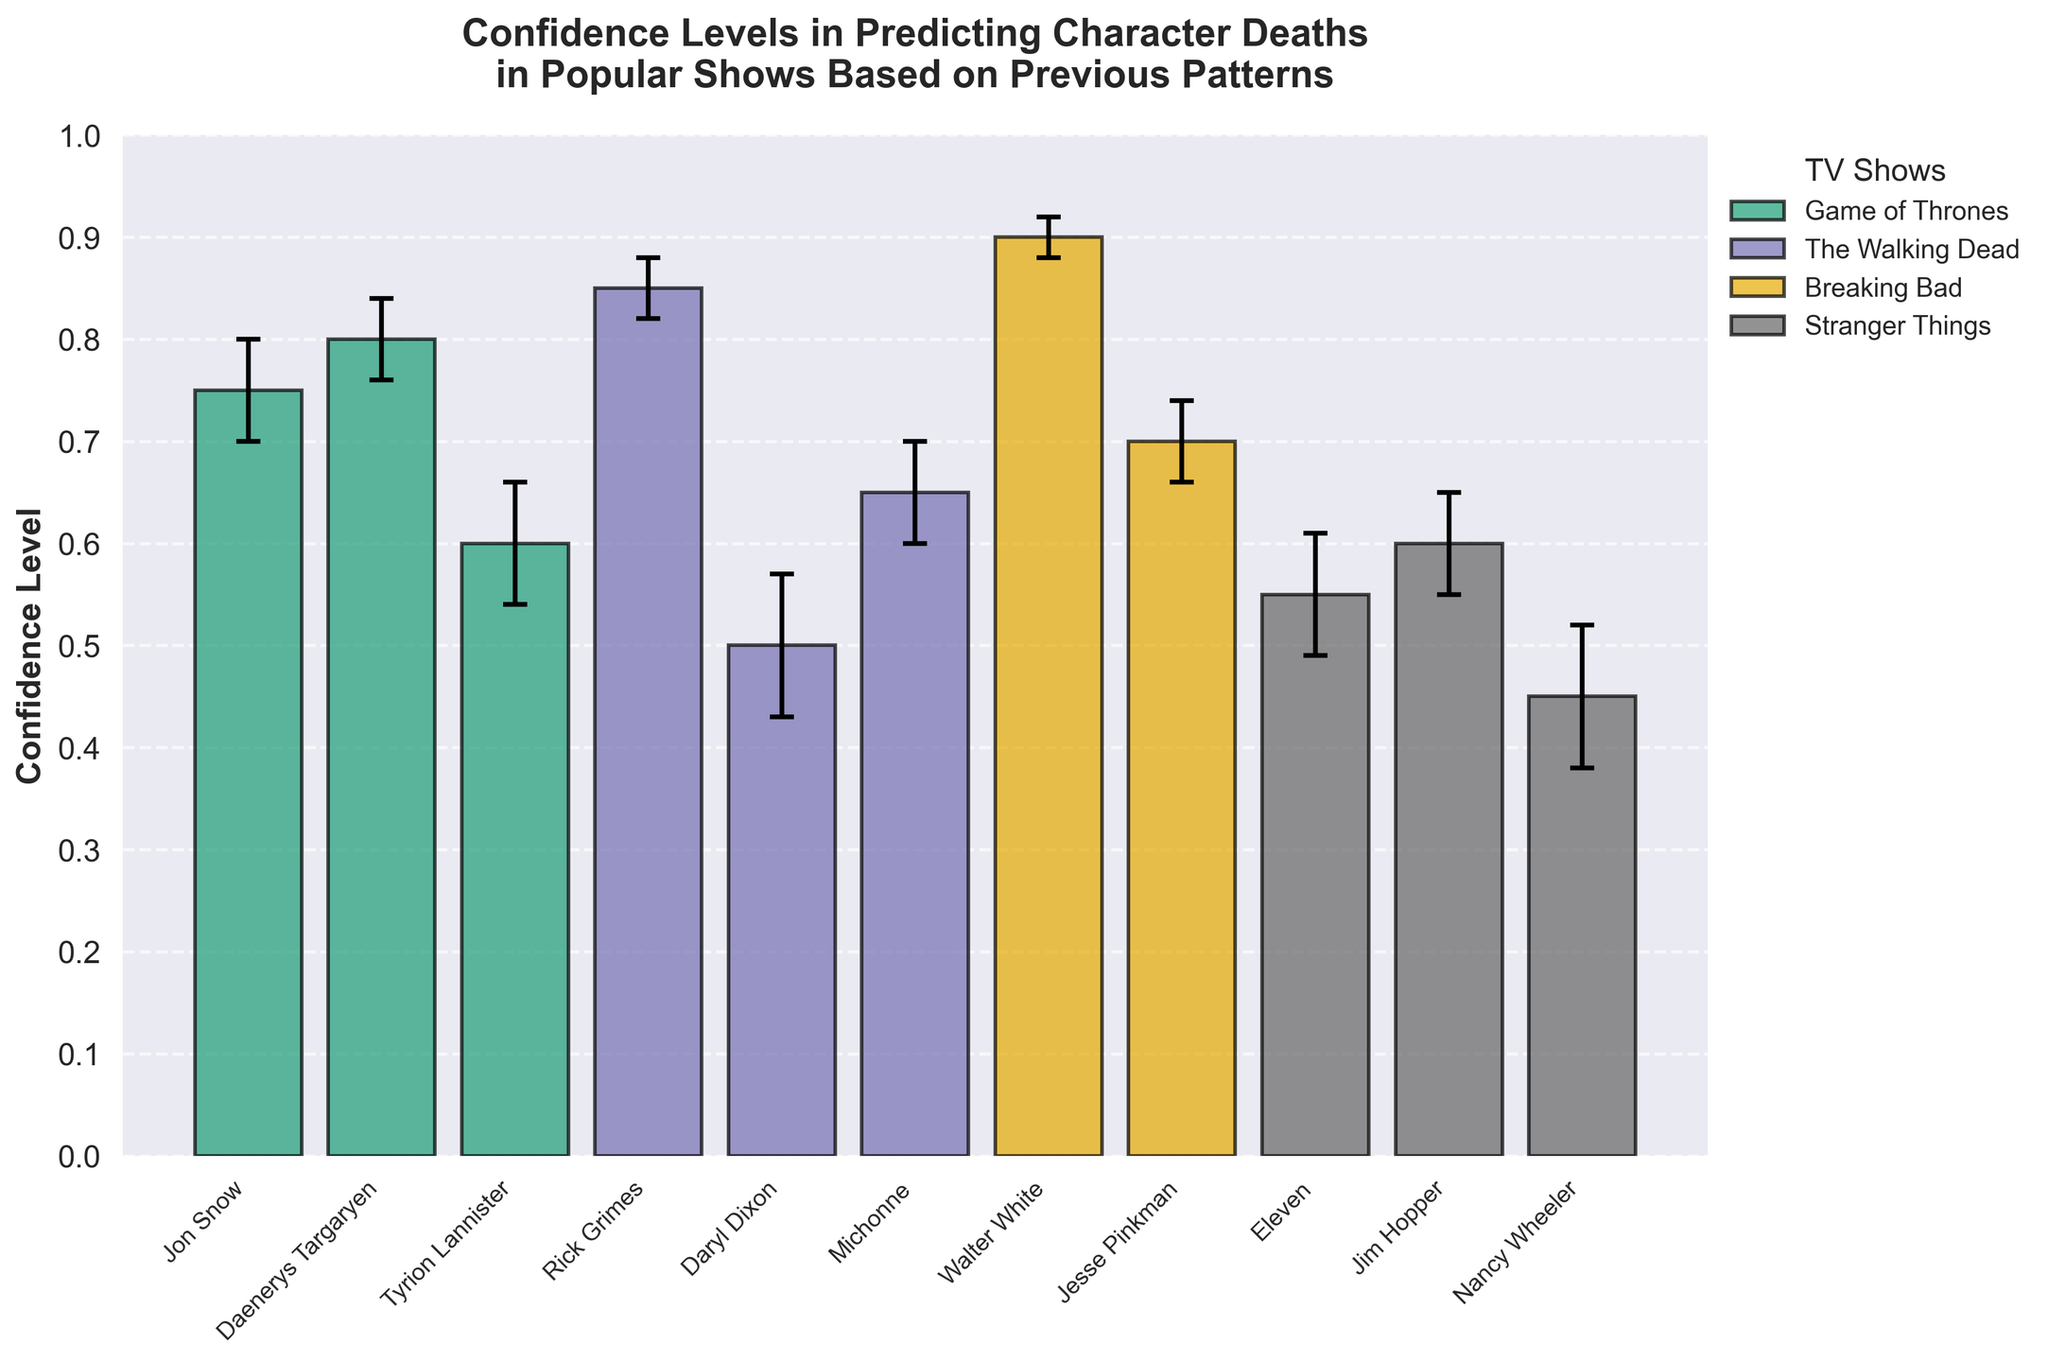What is the confidence level in predicting Jon Snow's death? The confidence level for Jon Snow can be found by looking at the bar corresponding to Jon Snow on the x-axis. The height of the bar shows the confidence level.
Answer: 0.75 Which character has the highest confidence level in predicting their death? To find the character with the highest confidence level, look for the tallest bar. The tallest bar on the plot corresponds to Walter White.
Answer: Walter White What is the smallest standard error observed in the plot, and which character does it belong to? Look for the shortest error bar on the plot. The shortest error bar belongs to Walter White.
Answer: 0.02, Walter White How do the confidence levels of Jon Snow and Daenerys Targaryen compare? To compare the confidence levels, refer to the heights of the bars for both Jon Snow and Daenerys Targaryen. Daenerys Targaryen has a higher bar.
Answer: Daenerys Targaryen has a higher confidence level than Jon Snow What is the average confidence level of characters from The Walking Dead? Identify the confidence levels of all characters from The Walking Dead: Rick Grimes (0.85), Daryl Dixon (0.50), and Michonne (0.65). Calculate the average: (0.85 + 0.50 + 0.65) / 3.
Answer: (0.85 + 0.50 + 0.65) / 3 = 0.67 Which show has the most characters listed in the plot? Count the number of characters listed for each show. The Walking Dead has 3 characters, the most among the shows.
Answer: The Walking Dead For Stranger Things, what is the difference in confidence levels between Eleven and Nancy Wheeler? Locate the bars for Eleven (0.55) and Nancy Wheeler (0.45). Calculate the difference: 0.55 - 0.45.
Answer: 0.10 Is there any character with a confidence level lower than 0.5, and if so, who are they? Look for bars with heights lower than 0.5. Nancy Wheeler is the character with a confidence level lower than 0.5.
Answer: Nancy Wheeler How does the standard error for Rick Grimes compare to Jon Snow? Compare the length of the error bars for Rick Grimes and Jon Snow. Rick Grimes has a shorter error bar.
Answer: Rick Grimes' standard error is smaller than Jon Snow's 